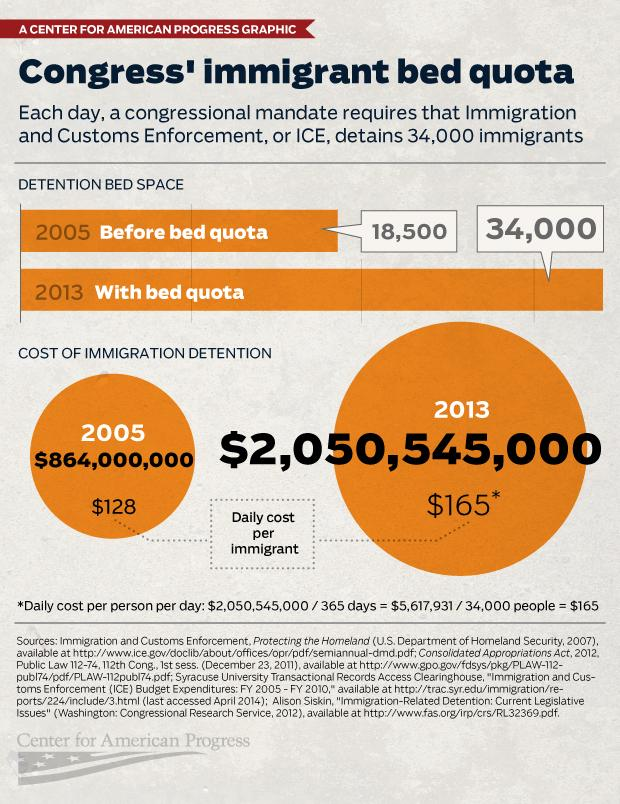Mention a couple of crucial points in this snapshot. The cost of immigration detention for the year 2013 was $2,050,545,000. In 2013, the cost per immigrant per day was equal to $165. In the year 2005, the cost of immigration detention was $864,000,000. In 2005, approximately 18,500 immigrants were able to be detained each day. In 2005, the daily cost per immigrant was equal to $128. 